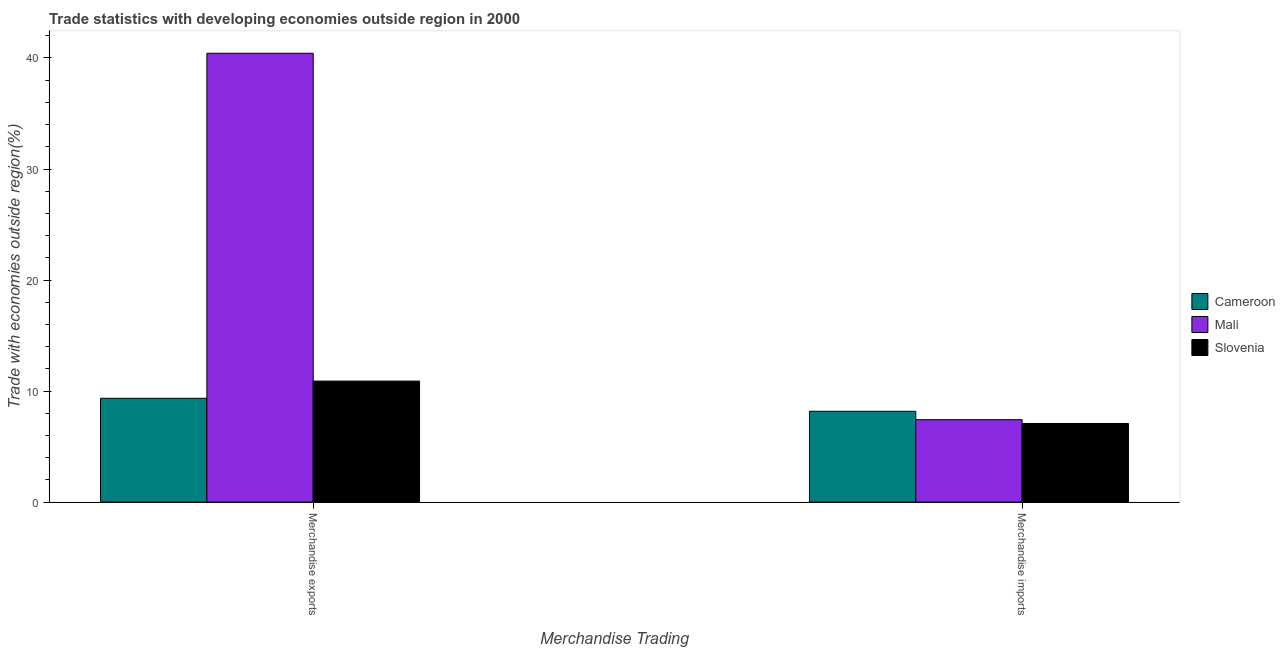How many groups of bars are there?
Offer a very short reply. 2. Are the number of bars per tick equal to the number of legend labels?
Offer a terse response. Yes. Are the number of bars on each tick of the X-axis equal?
Provide a succinct answer. Yes. How many bars are there on the 1st tick from the right?
Give a very brief answer. 3. What is the merchandise imports in Mali?
Give a very brief answer. 7.42. Across all countries, what is the maximum merchandise exports?
Ensure brevity in your answer.  40.42. Across all countries, what is the minimum merchandise exports?
Provide a succinct answer. 9.35. In which country was the merchandise imports maximum?
Offer a terse response. Cameroon. In which country was the merchandise imports minimum?
Keep it short and to the point. Slovenia. What is the total merchandise imports in the graph?
Offer a terse response. 22.69. What is the difference between the merchandise exports in Cameroon and that in Mali?
Give a very brief answer. -31.07. What is the difference between the merchandise exports in Slovenia and the merchandise imports in Cameroon?
Provide a short and direct response. 2.72. What is the average merchandise exports per country?
Ensure brevity in your answer.  20.22. What is the difference between the merchandise imports and merchandise exports in Slovenia?
Give a very brief answer. -3.82. What is the ratio of the merchandise exports in Cameroon to that in Mali?
Keep it short and to the point. 0.23. Is the merchandise exports in Slovenia less than that in Mali?
Provide a succinct answer. Yes. What does the 2nd bar from the left in Merchandise exports represents?
Keep it short and to the point. Mali. What does the 2nd bar from the right in Merchandise imports represents?
Your response must be concise. Mali. Are all the bars in the graph horizontal?
Offer a terse response. No. How many countries are there in the graph?
Provide a succinct answer. 3. What is the difference between two consecutive major ticks on the Y-axis?
Ensure brevity in your answer.  10. Are the values on the major ticks of Y-axis written in scientific E-notation?
Keep it short and to the point. No. Where does the legend appear in the graph?
Your answer should be very brief. Center right. How many legend labels are there?
Your response must be concise. 3. How are the legend labels stacked?
Give a very brief answer. Vertical. What is the title of the graph?
Your answer should be very brief. Trade statistics with developing economies outside region in 2000. What is the label or title of the X-axis?
Offer a very short reply. Merchandise Trading. What is the label or title of the Y-axis?
Provide a succinct answer. Trade with economies outside region(%). What is the Trade with economies outside region(%) of Cameroon in Merchandise exports?
Your answer should be very brief. 9.35. What is the Trade with economies outside region(%) of Mali in Merchandise exports?
Keep it short and to the point. 40.42. What is the Trade with economies outside region(%) of Slovenia in Merchandise exports?
Provide a short and direct response. 10.9. What is the Trade with economies outside region(%) in Cameroon in Merchandise imports?
Keep it short and to the point. 8.18. What is the Trade with economies outside region(%) in Mali in Merchandise imports?
Your answer should be very brief. 7.42. What is the Trade with economies outside region(%) of Slovenia in Merchandise imports?
Give a very brief answer. 7.08. Across all Merchandise Trading, what is the maximum Trade with economies outside region(%) of Cameroon?
Give a very brief answer. 9.35. Across all Merchandise Trading, what is the maximum Trade with economies outside region(%) of Mali?
Make the answer very short. 40.42. Across all Merchandise Trading, what is the maximum Trade with economies outside region(%) of Slovenia?
Provide a succinct answer. 10.9. Across all Merchandise Trading, what is the minimum Trade with economies outside region(%) in Cameroon?
Offer a very short reply. 8.18. Across all Merchandise Trading, what is the minimum Trade with economies outside region(%) of Mali?
Make the answer very short. 7.42. Across all Merchandise Trading, what is the minimum Trade with economies outside region(%) of Slovenia?
Make the answer very short. 7.08. What is the total Trade with economies outside region(%) of Cameroon in the graph?
Keep it short and to the point. 17.53. What is the total Trade with economies outside region(%) in Mali in the graph?
Make the answer very short. 47.85. What is the total Trade with economies outside region(%) of Slovenia in the graph?
Your answer should be very brief. 17.98. What is the difference between the Trade with economies outside region(%) in Cameroon in Merchandise exports and that in Merchandise imports?
Your answer should be compact. 1.17. What is the difference between the Trade with economies outside region(%) of Mali in Merchandise exports and that in Merchandise imports?
Offer a terse response. 33. What is the difference between the Trade with economies outside region(%) of Slovenia in Merchandise exports and that in Merchandise imports?
Keep it short and to the point. 3.82. What is the difference between the Trade with economies outside region(%) in Cameroon in Merchandise exports and the Trade with economies outside region(%) in Mali in Merchandise imports?
Your answer should be very brief. 1.93. What is the difference between the Trade with economies outside region(%) of Cameroon in Merchandise exports and the Trade with economies outside region(%) of Slovenia in Merchandise imports?
Your answer should be very brief. 2.27. What is the difference between the Trade with economies outside region(%) in Mali in Merchandise exports and the Trade with economies outside region(%) in Slovenia in Merchandise imports?
Give a very brief answer. 33.34. What is the average Trade with economies outside region(%) of Cameroon per Merchandise Trading?
Your response must be concise. 8.77. What is the average Trade with economies outside region(%) of Mali per Merchandise Trading?
Ensure brevity in your answer.  23.92. What is the average Trade with economies outside region(%) in Slovenia per Merchandise Trading?
Provide a succinct answer. 8.99. What is the difference between the Trade with economies outside region(%) of Cameroon and Trade with economies outside region(%) of Mali in Merchandise exports?
Your answer should be very brief. -31.07. What is the difference between the Trade with economies outside region(%) in Cameroon and Trade with economies outside region(%) in Slovenia in Merchandise exports?
Your answer should be very brief. -1.55. What is the difference between the Trade with economies outside region(%) in Mali and Trade with economies outside region(%) in Slovenia in Merchandise exports?
Keep it short and to the point. 29.52. What is the difference between the Trade with economies outside region(%) in Cameroon and Trade with economies outside region(%) in Mali in Merchandise imports?
Give a very brief answer. 0.76. What is the difference between the Trade with economies outside region(%) of Mali and Trade with economies outside region(%) of Slovenia in Merchandise imports?
Your answer should be compact. 0.34. What is the ratio of the Trade with economies outside region(%) of Mali in Merchandise exports to that in Merchandise imports?
Keep it short and to the point. 5.45. What is the ratio of the Trade with economies outside region(%) of Slovenia in Merchandise exports to that in Merchandise imports?
Offer a terse response. 1.54. What is the difference between the highest and the second highest Trade with economies outside region(%) of Cameroon?
Provide a short and direct response. 1.17. What is the difference between the highest and the second highest Trade with economies outside region(%) in Mali?
Keep it short and to the point. 33. What is the difference between the highest and the second highest Trade with economies outside region(%) of Slovenia?
Keep it short and to the point. 3.82. What is the difference between the highest and the lowest Trade with economies outside region(%) of Cameroon?
Ensure brevity in your answer.  1.17. What is the difference between the highest and the lowest Trade with economies outside region(%) in Mali?
Offer a terse response. 33. What is the difference between the highest and the lowest Trade with economies outside region(%) of Slovenia?
Offer a very short reply. 3.82. 